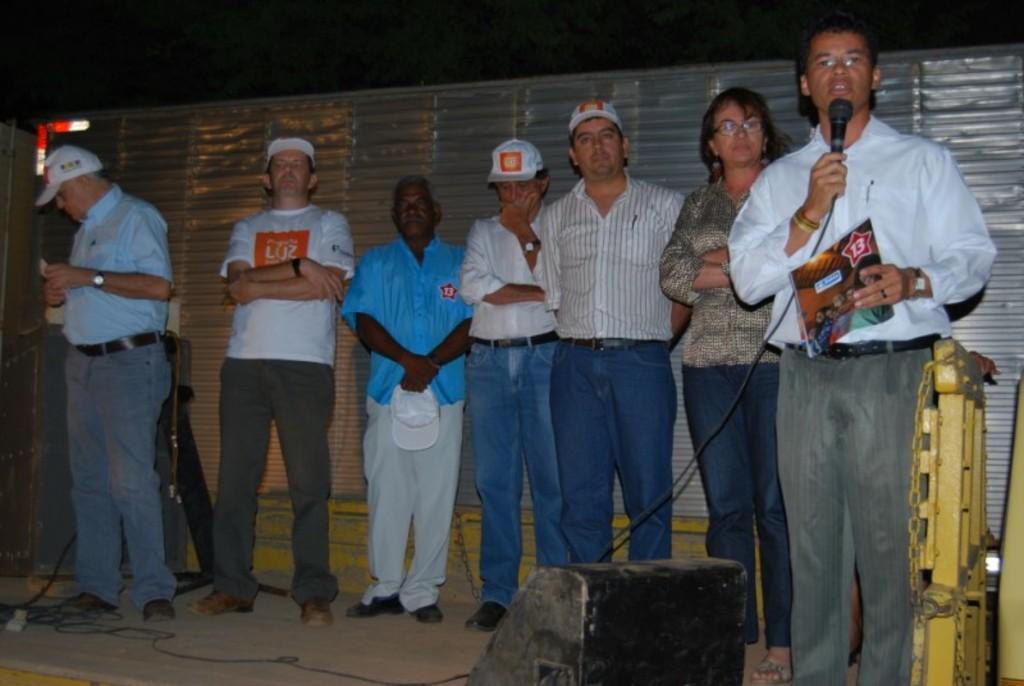How would you summarize this image in a sentence or two? This picture shows few people standing and few of them wore caps on their heads and we see a man holding a paper in his hand and speaking with the help of a microphone and we see a speaker and we see couple of them wore spectacles on their faces and we see a man holding a cap in his hand. 